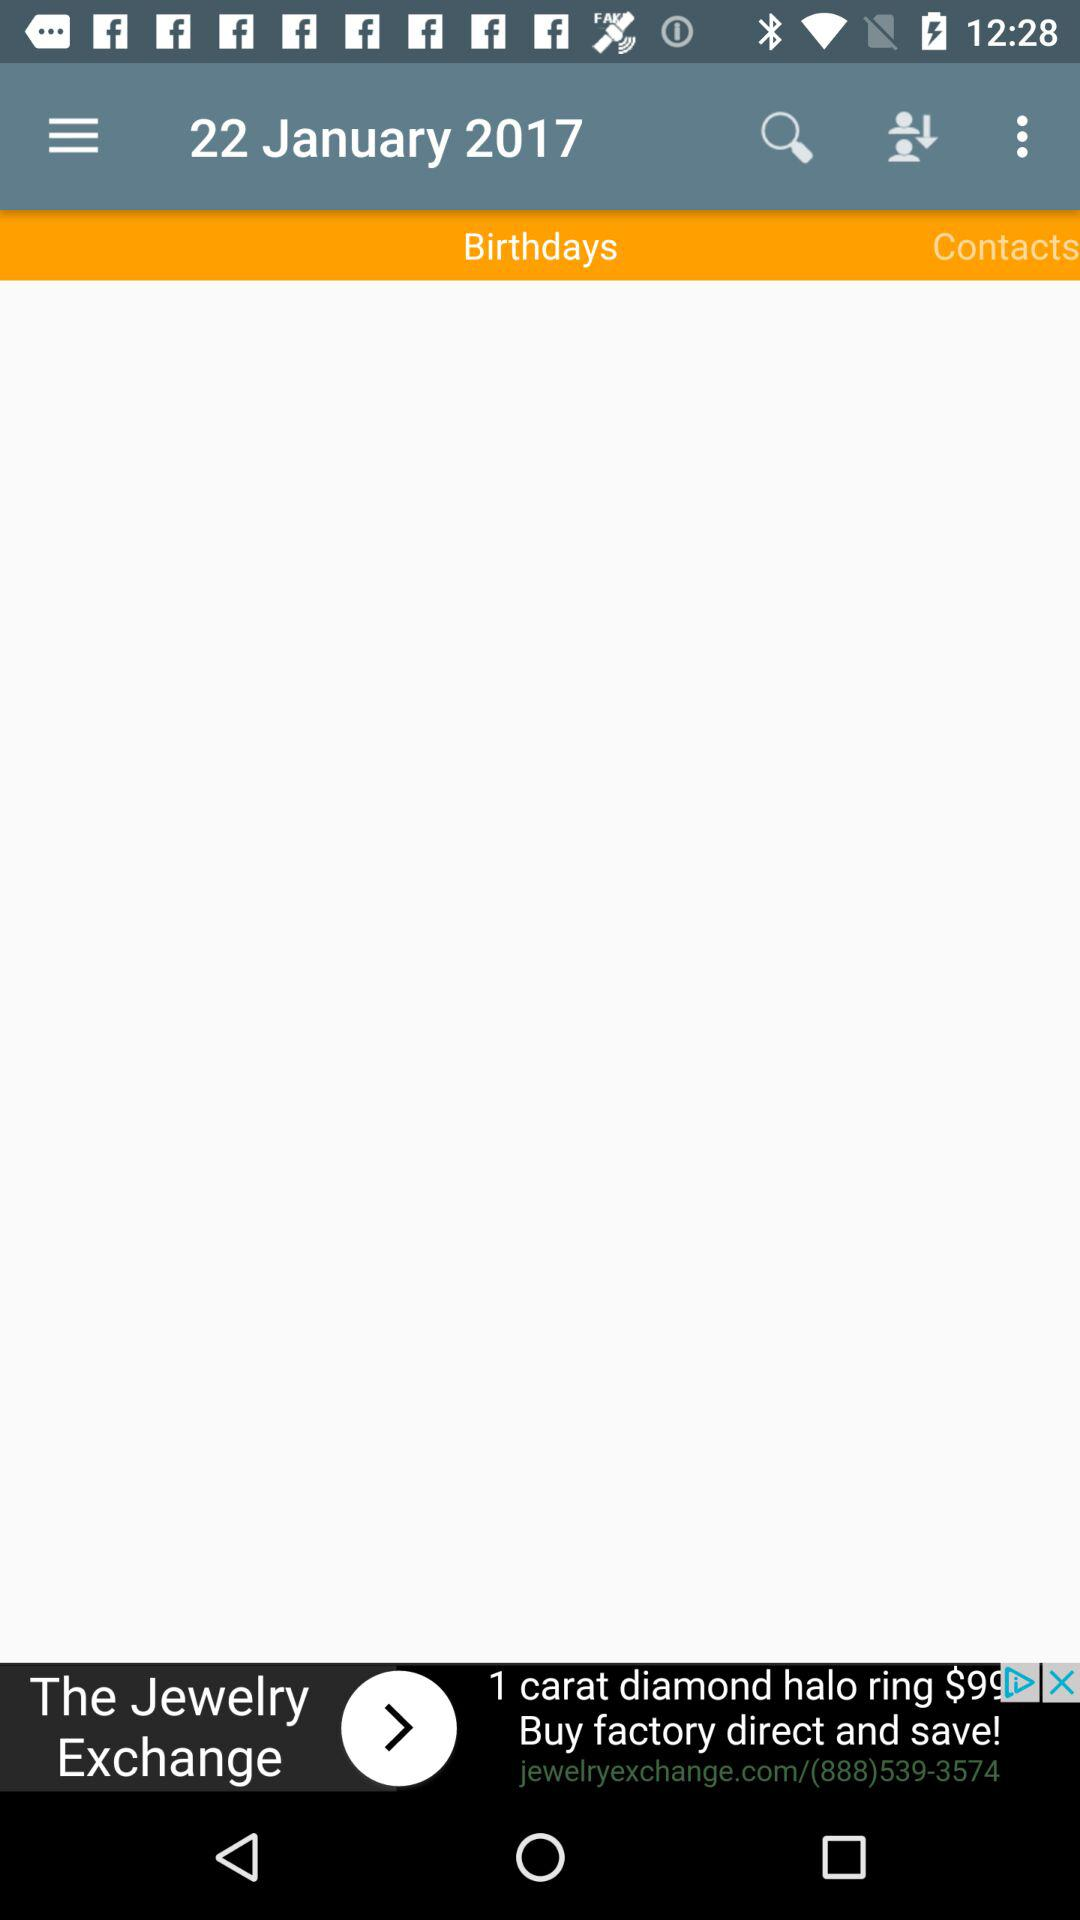What date is shown on the screen? The date shown on the screen is January 22, 2017. 